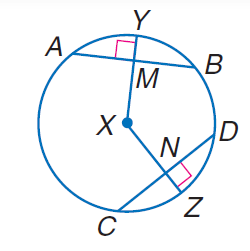Answer the mathemtical geometry problem and directly provide the correct option letter.
Question: In \odot X, A B = 30, C D = 30, and m \widehat C Z = 40. Find A M.
Choices: A: 10 B: 15 C: 20 D: 30 B 